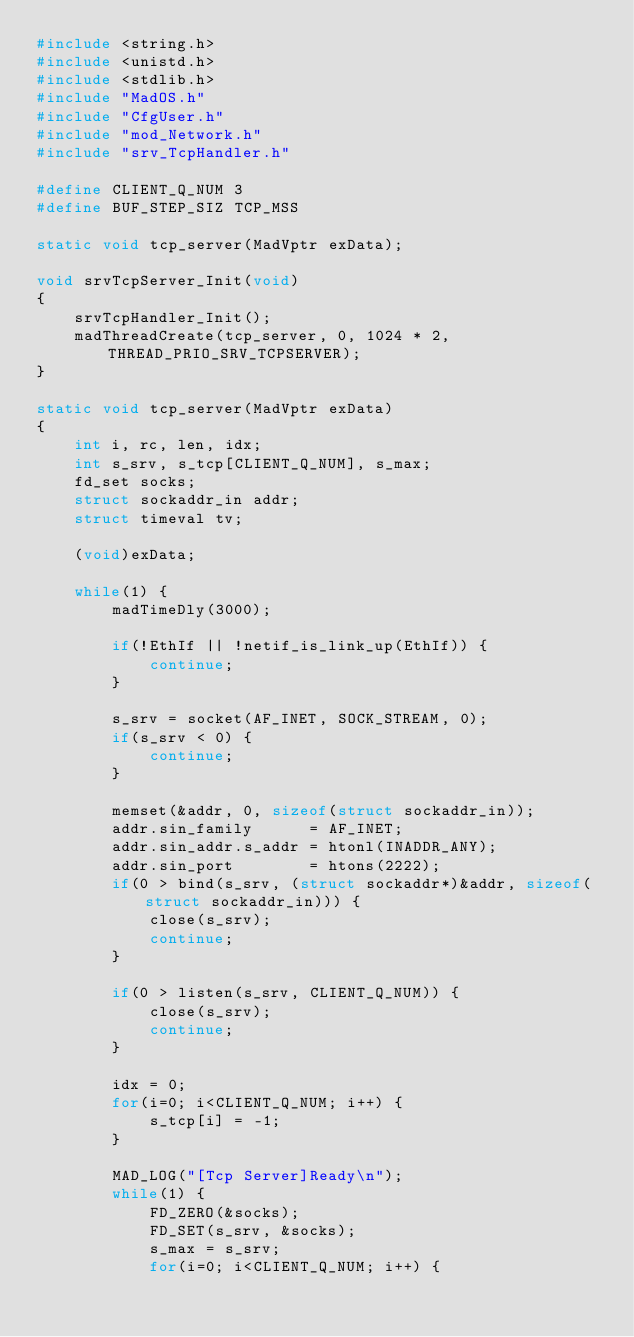<code> <loc_0><loc_0><loc_500><loc_500><_C_>#include <string.h>
#include <unistd.h>
#include <stdlib.h>
#include "MadOS.h"
#include "CfgUser.h"
#include "mod_Network.h"
#include "srv_TcpHandler.h"

#define CLIENT_Q_NUM 3
#define BUF_STEP_SIZ TCP_MSS

static void tcp_server(MadVptr exData);

void srvTcpServer_Init(void)
{
    srvTcpHandler_Init();
    madThreadCreate(tcp_server, 0, 1024 * 2, THREAD_PRIO_SRV_TCPSERVER);
}

static void tcp_server(MadVptr exData)
{
    int i, rc, len, idx;
    int s_srv, s_tcp[CLIENT_Q_NUM], s_max;
    fd_set socks;
    struct sockaddr_in addr;
    struct timeval tv;

    (void)exData;

    while(1) {
        madTimeDly(3000);

        if(!EthIf || !netif_is_link_up(EthIf)) {
            continue;
        }

        s_srv = socket(AF_INET, SOCK_STREAM, 0);
        if(s_srv < 0) {
            continue;
        }

        memset(&addr, 0, sizeof(struct sockaddr_in));
        addr.sin_family      = AF_INET;
        addr.sin_addr.s_addr = htonl(INADDR_ANY);
        addr.sin_port        = htons(2222);
        if(0 > bind(s_srv, (struct sockaddr*)&addr, sizeof(struct sockaddr_in))) {
            close(s_srv);
            continue;
        }

        if(0 > listen(s_srv, CLIENT_Q_NUM)) {
            close(s_srv);
            continue;
        }

        idx = 0;
        for(i=0; i<CLIENT_Q_NUM; i++) {
            s_tcp[i] = -1;
        }

        MAD_LOG("[Tcp Server]Ready\n");
        while(1) {
            FD_ZERO(&socks);
            FD_SET(s_srv, &socks);
            s_max = s_srv;
            for(i=0; i<CLIENT_Q_NUM; i++) {</code> 